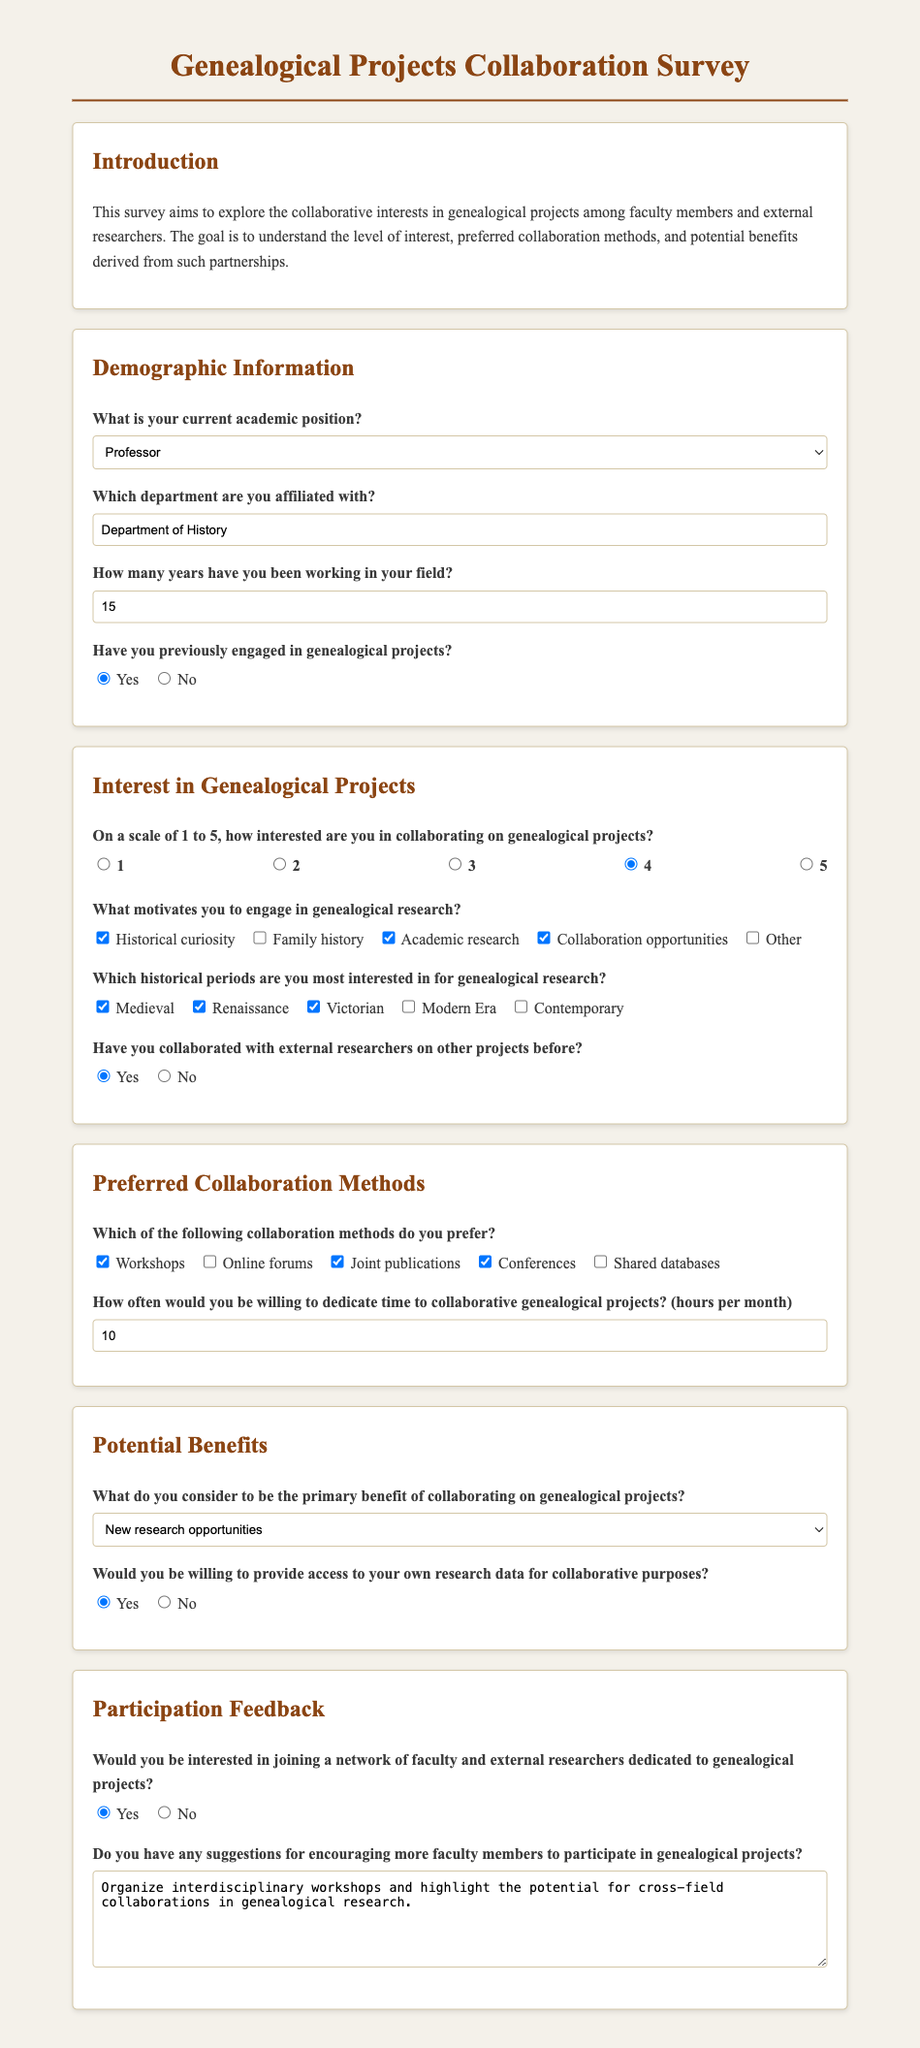What is your current academic position? This question is asking for the position of the respondent, and the options provided include Professor, Associate Professor, Assistant Professor, Lecturer, and Researcher. The selected answer is Professor.
Answer: Professor Which department are you affiliated with? This question seeks to identify the respondent's department, and the filled-in answer is the Department of History.
Answer: Department of History How many years have you been working in your field? This question asks for the duration of experience in years, which the respondent indicated as 15.
Answer: 15 What is your interest level in collaborating on genealogical projects? The respondent's rating on a scale of 1 to 5, with the selected answer being 4.
Answer: 4 What motivates you to engage in genealogical research? The question lists several motivations, and the respondent selected Historical curiosity, Academic research, and Collaboration opportunities.
Answer: Historical curiosity, Academic research, Collaboration opportunities What is the primary benefit of collaborating on genealogical projects according to the respondent? The respondent chose New research opportunities as the primary benefit from the options given.
Answer: New research opportunities How many hours per month would you be willing to dedicate to collaborative genealogical projects? The respondent provided a numerical answer for the time dedicated, which is 10 hours.
Answer: 10 Would you be willing to provide access to your own research data for collaborative purposes? This question examines whether the respondent is open to sharing data, and the selected answer is Yes.
Answer: Yes Do you have any suggestions for encouraging more faculty members to participate in genealogical projects? The respondent gave feedback in a textarea, suggesting organizing interdisciplinary workshops and highlighting collaboration potentials.
Answer: Organize interdisciplinary workshops and highlight the potential for cross-field collaborations in genealogical research 